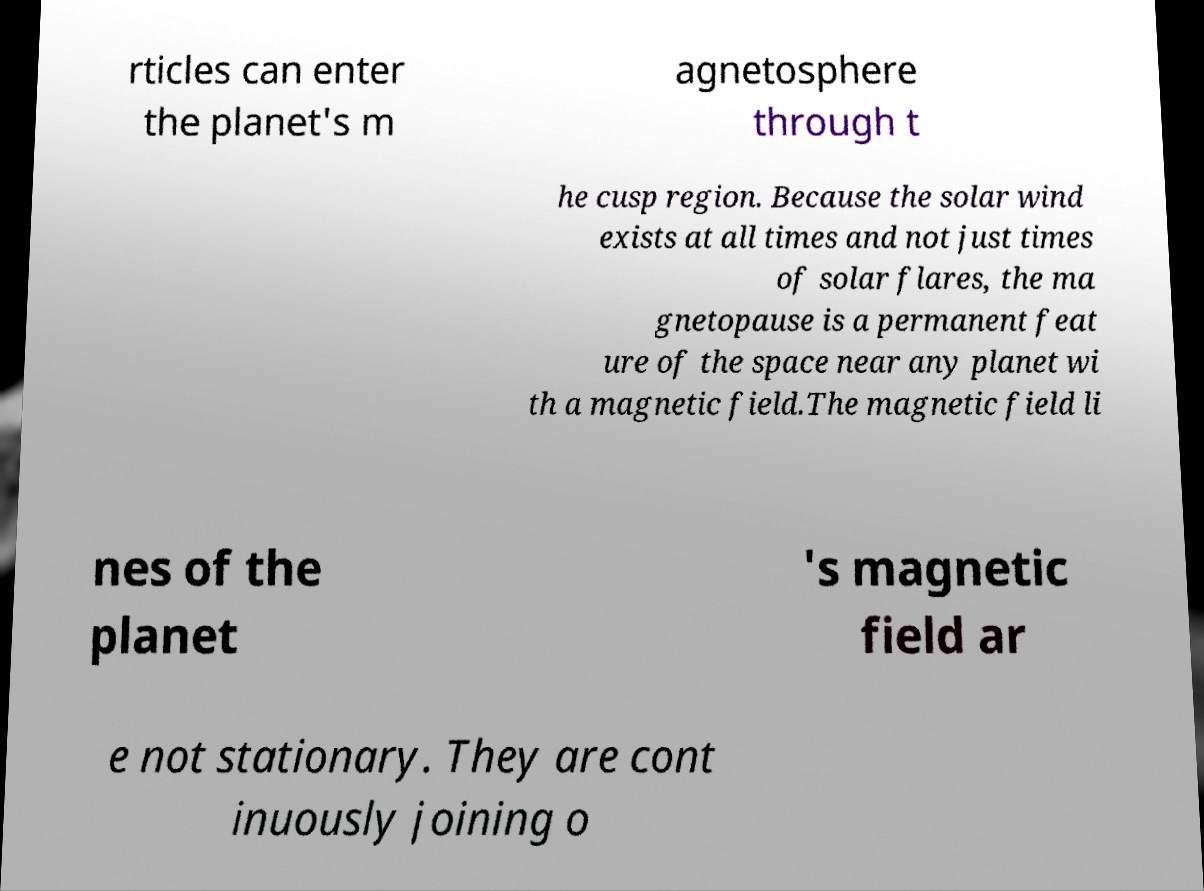Could you extract and type out the text from this image? rticles can enter the planet's m agnetosphere through t he cusp region. Because the solar wind exists at all times and not just times of solar flares, the ma gnetopause is a permanent feat ure of the space near any planet wi th a magnetic field.The magnetic field li nes of the planet 's magnetic field ar e not stationary. They are cont inuously joining o 